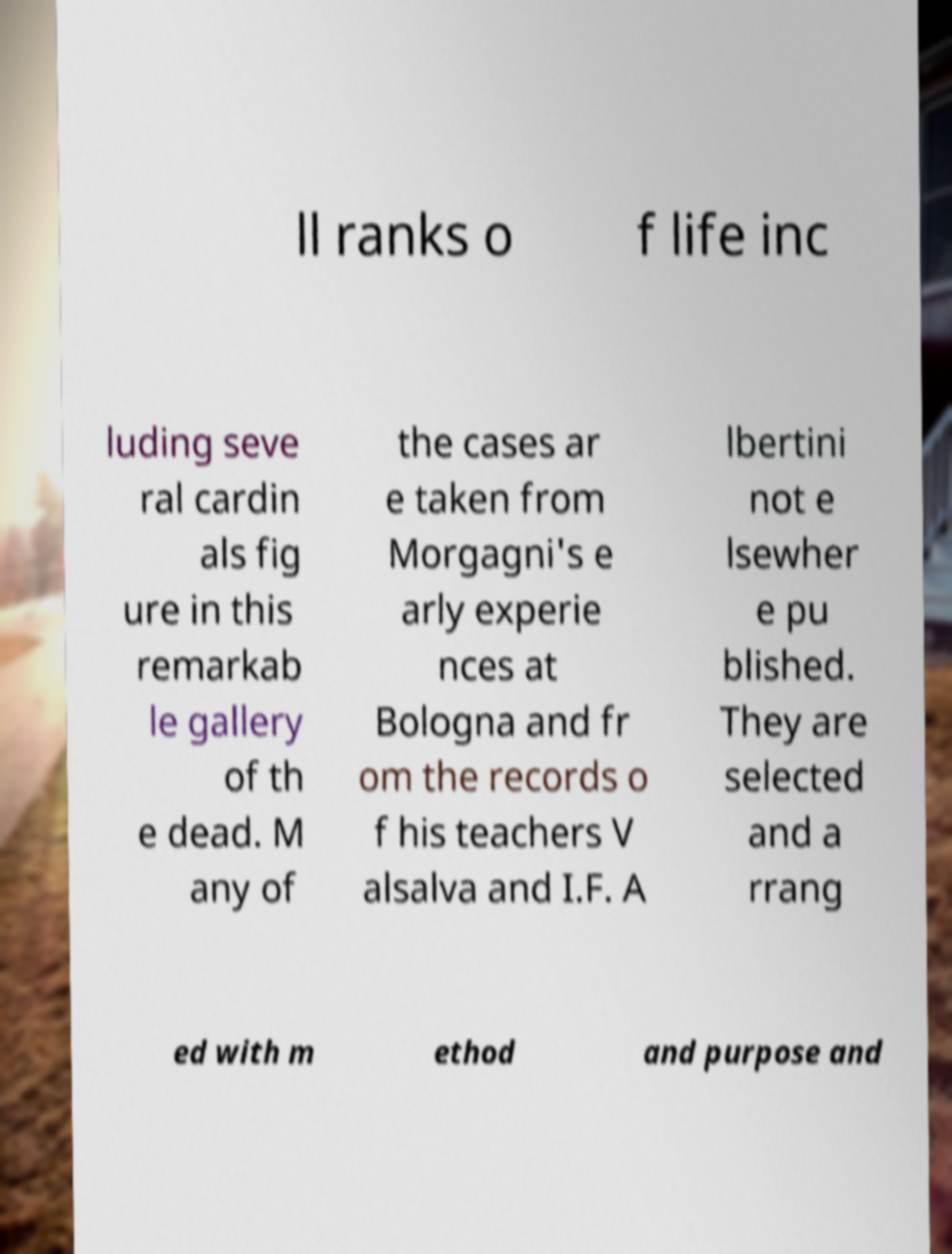Could you extract and type out the text from this image? ll ranks o f life inc luding seve ral cardin als fig ure in this remarkab le gallery of th e dead. M any of the cases ar e taken from Morgagni's e arly experie nces at Bologna and fr om the records o f his teachers V alsalva and I.F. A lbertini not e lsewher e pu blished. They are selected and a rrang ed with m ethod and purpose and 